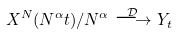<formula> <loc_0><loc_0><loc_500><loc_500>X ^ { N } ( N ^ { \alpha } t ) / N ^ { \alpha } \stackrel { \mathcal { D } } { \longrightarrow } Y _ { t }</formula> 